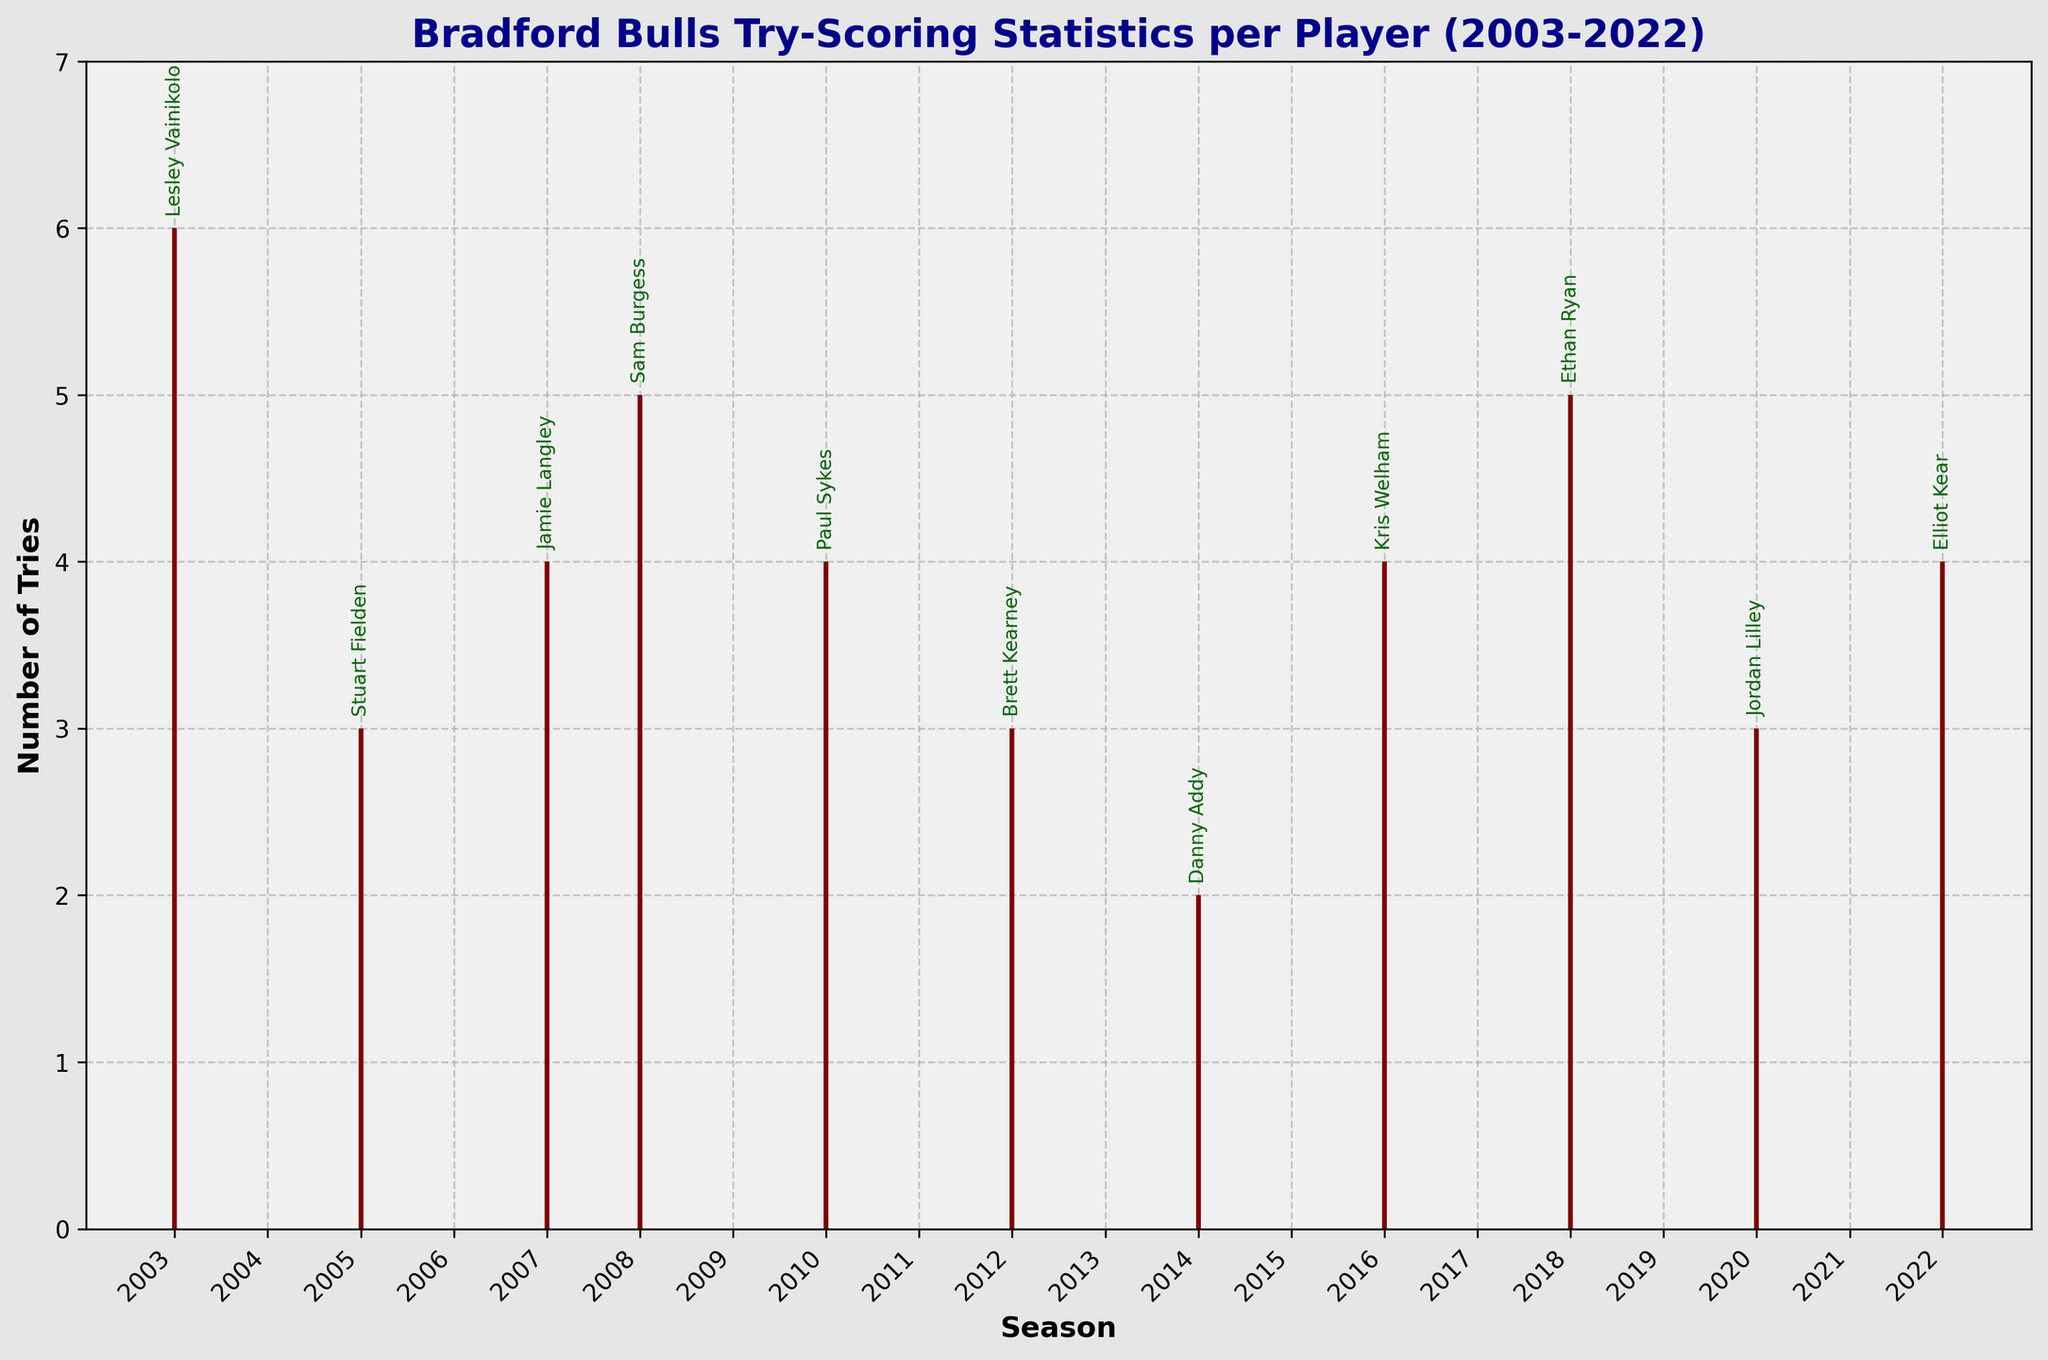When is Lesley Vainikolo's peak try-scoring performance? According to the OHLC chart, Lesley Vainikolo's peak try-scoring performance in 2003 is marked at 6 tries.
Answer: 6 Which player had the highest number of tries in their first game of any season? The chart shows that both Lesley Vainikolo in 2003 and Ethan Ryan in 2018 had 2 tries in their respective first games, which are the highest numbers.
Answer: Lesley Vainikolo, Ethan Ryan What's the range of tries for Stuart Fielden in the 2005 season? The range can be calculated by subtracting the lowest number of tries (0) from the peak number of tries (3). Therefore, the range is 3.
Answer: 3 How many players had their peak number of tries at 4? The players with their peak number of tries at 4, as seen in the plot, are Jamie Langley in 2007, Paul Sykes in 2010, Kris Welham in 2016, and Elliot Kear in 2022. This amounts to 4 players.
Answer: 4 Who had a higher number of tries in their final game, Sam Burgess in 2008 or Brett Kearney in 2012? The chart shows that Sam Burgess had 3 tries in his final game in 2008, while Brett Kearney had 2 tries in his final game in 2012. Therefore, Sam Burgess had more tries.
Answer: Sam Burgess Are there any players whose lowest game performance was greater than zero? The lowest game performance for all players listed in the chart is recorded as zero tries.
Answer: No What is the median peak try-scoring performance of the players? To calculate the median peak try-scoring performance, list all the peak values (6, 3, 4, 5, 4, 3, 2, 4, 5, 3, 4) in order (2, 3, 3, 3, 4, 4, 4, 4, 5, 5, 6). The median value is the middle number, which is 4.
Answer: 4 Who had a higher peak performance, Jordan Lilley in 2020 or Danny Addy in 2014? According to the chart, Jordan Lilley had a peak performance of 3 tries in 2020, while Danny Addy had a peak performance of 2 tries in 2014. Therefore, Jordan Lilley had a higher peak performance.
Answer: Jordan Lilley How many players had a final game performance of 1 try? Jamie Langley in 2007, Paul Sykes in 2010, and Danny Addy in 2014 had a final game performance of 1 try each. This totals to 3 players.
Answer: 3 